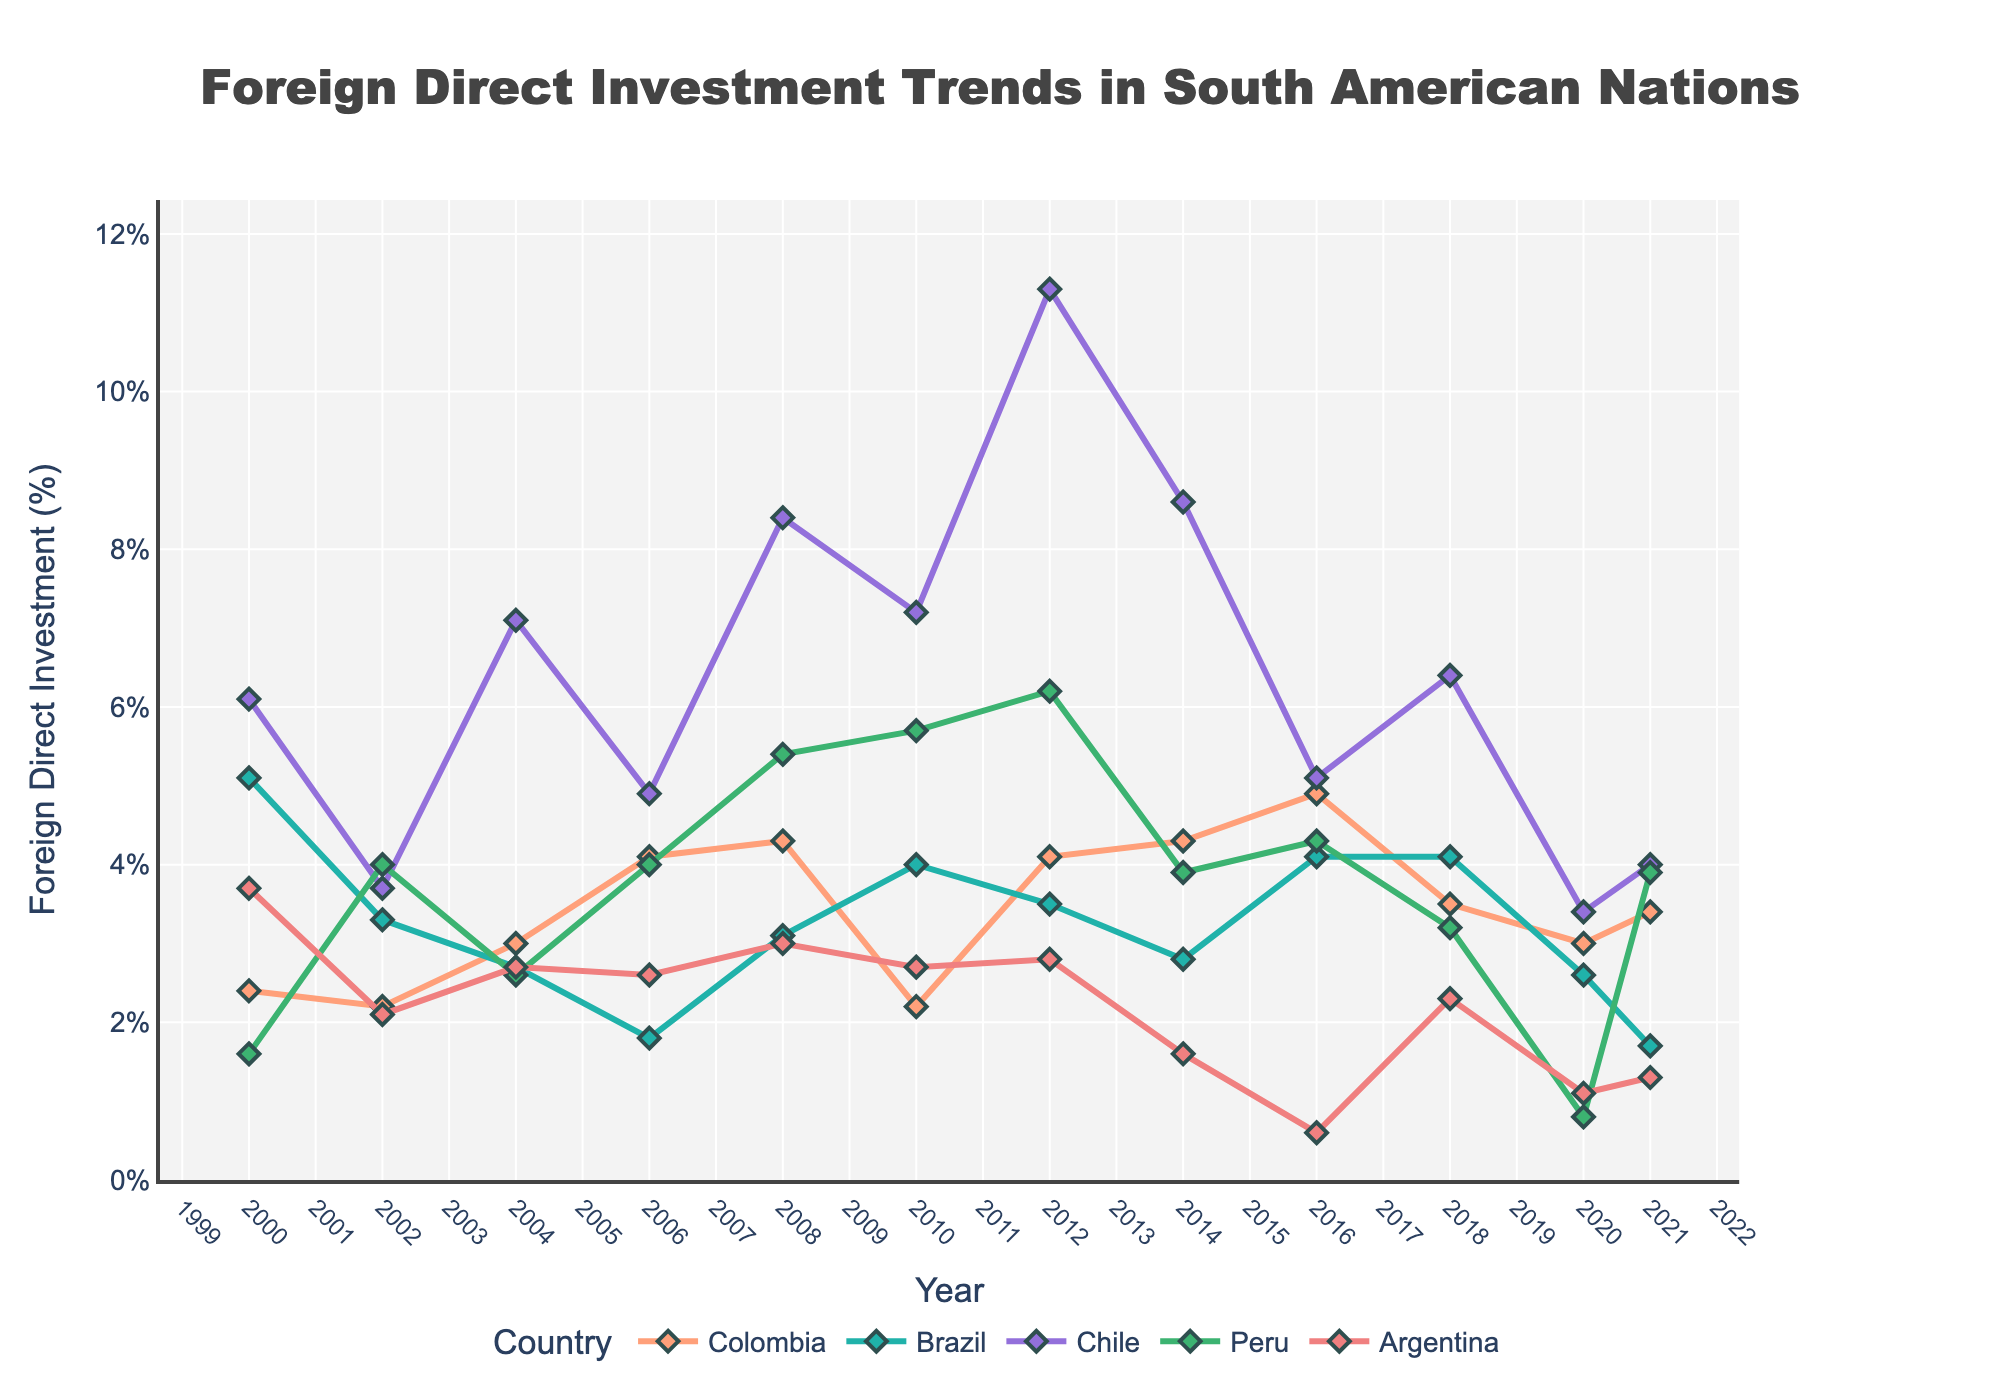Which country had the highest Foreign Direct Investment (FDI) in 2008? To find this, we look at the data points for each country in 2008. Among Colombia, Brazil, Chile, Peru, and Argentina, Chile had the highest FDI.
Answer: Chile What is the average FDI of Colombia from 2016 to 2021? To calculate the average, sum the values of FDI for Colombia from 2016 to 2021 and then divide by the number of years. (4.9 + 3.5 + 3.0 + 3.4) / 4 = 14.8 / 4 = 3.7
Answer: 3.7 Between which years did Argentina's FDI drop the most? Examine the data points for Argentina year by year and identify the largest decline between consecutive years. The largest drop is between 2016 and 2018, from 0.6 to 2.3.
Answer: 2016 to 2018 Which country had the most stable FDI trend, showing the least fluctuation, since 2000? Observe the lines for each country and identify which one has the least variation over time. Brazil's FDI shows relatively stable and less fluctuating trends.
Answer: Brazil In which year did Peru have its highest FDI value? Examine the FDI values for Peru over the years and find the highest one. Peru's highest FDI value was in 2012, with 6.2%.
Answer: 2012 How does Colombia's FDI in 2020 compare to Chile's? Look at the FDI values for Colombia and Chile in 2020. Colombia's FDI in 2020 was 3.0%, while Chile's was 3.4%.
Answer: Chile's is higher What is the general trend of FDI in South American countries from 2000 to 2021? Analyze the overall direction of the lines for each country. Generally, FDI shows an increasing trend until around 2012 and then fluctuates without a clear upward or downward trend.
Answer: Increasing until 2012, then fluctuating Which country's FDI peaked later than the others? Observe the peak FDI for each country and when it occurred. Chile's FDI peaked in 2012, which is later compared to the peaks of other countries.
Answer: Chile Calculate the difference between Colombia's highest and lowest FDI values from 2000 to 2021. Identify the highest and lowest FDI values for Colombia and subtract the smallest from the largest. The highest is 4.9 (2016) and the lowest is 2.2 (2002 and 2010). 4.9 - 2.2 = 2.7
Answer: 2.7 Which country showed an FDI decline between 2018 and 2020 while others remained relatively steady or increased? Examine the FDI values for all countries from 2018 to 2020. Argentina's FDI declined from 2.3 in 2018 to 1.1 in 2020.
Answer: Argentina 